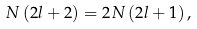<formula> <loc_0><loc_0><loc_500><loc_500>N \left ( 2 l + 2 \right ) = 2 N \left ( 2 l + 1 \right ) ,</formula> 